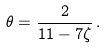<formula> <loc_0><loc_0><loc_500><loc_500>\theta = \frac { 2 } { 1 1 - 7 \zeta } \, .</formula> 